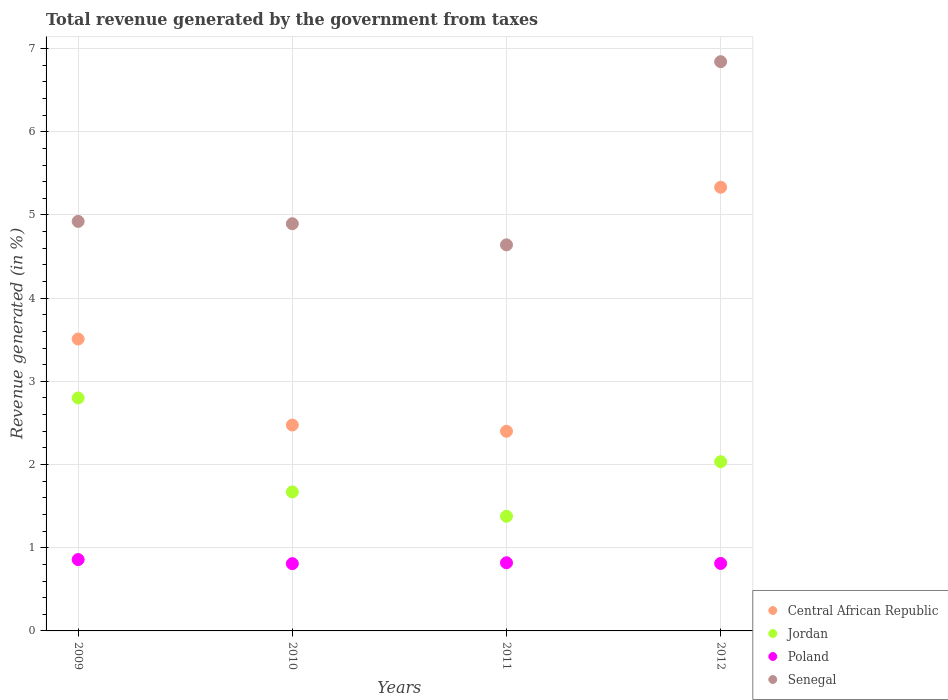How many different coloured dotlines are there?
Make the answer very short. 4. Is the number of dotlines equal to the number of legend labels?
Your answer should be compact. Yes. What is the total revenue generated in Poland in 2012?
Your answer should be very brief. 0.81. Across all years, what is the maximum total revenue generated in Senegal?
Provide a short and direct response. 6.84. Across all years, what is the minimum total revenue generated in Central African Republic?
Your response must be concise. 2.4. What is the total total revenue generated in Jordan in the graph?
Offer a terse response. 7.88. What is the difference between the total revenue generated in Central African Republic in 2011 and that in 2012?
Provide a short and direct response. -2.93. What is the difference between the total revenue generated in Jordan in 2009 and the total revenue generated in Poland in 2010?
Make the answer very short. 1.99. What is the average total revenue generated in Central African Republic per year?
Your response must be concise. 3.43. In the year 2012, what is the difference between the total revenue generated in Jordan and total revenue generated in Senegal?
Ensure brevity in your answer.  -4.81. What is the ratio of the total revenue generated in Jordan in 2009 to that in 2011?
Your response must be concise. 2.03. Is the total revenue generated in Jordan in 2009 less than that in 2012?
Keep it short and to the point. No. Is the difference between the total revenue generated in Jordan in 2011 and 2012 greater than the difference between the total revenue generated in Senegal in 2011 and 2012?
Offer a very short reply. Yes. What is the difference between the highest and the second highest total revenue generated in Central African Republic?
Give a very brief answer. 1.82. What is the difference between the highest and the lowest total revenue generated in Jordan?
Offer a very short reply. 1.42. In how many years, is the total revenue generated in Poland greater than the average total revenue generated in Poland taken over all years?
Ensure brevity in your answer.  1. Is the sum of the total revenue generated in Jordan in 2011 and 2012 greater than the maximum total revenue generated in Central African Republic across all years?
Keep it short and to the point. No. Does the total revenue generated in Poland monotonically increase over the years?
Your answer should be very brief. No. Is the total revenue generated in Central African Republic strictly greater than the total revenue generated in Jordan over the years?
Ensure brevity in your answer.  Yes. Does the graph contain any zero values?
Your answer should be compact. No. Does the graph contain grids?
Your answer should be compact. Yes. Where does the legend appear in the graph?
Your answer should be very brief. Bottom right. How are the legend labels stacked?
Your answer should be very brief. Vertical. What is the title of the graph?
Make the answer very short. Total revenue generated by the government from taxes. Does "Saudi Arabia" appear as one of the legend labels in the graph?
Your response must be concise. No. What is the label or title of the Y-axis?
Your answer should be compact. Revenue generated (in %). What is the Revenue generated (in %) in Central African Republic in 2009?
Offer a very short reply. 3.51. What is the Revenue generated (in %) of Jordan in 2009?
Give a very brief answer. 2.8. What is the Revenue generated (in %) in Poland in 2009?
Your response must be concise. 0.86. What is the Revenue generated (in %) of Senegal in 2009?
Your answer should be compact. 4.92. What is the Revenue generated (in %) in Central African Republic in 2010?
Keep it short and to the point. 2.47. What is the Revenue generated (in %) of Jordan in 2010?
Provide a short and direct response. 1.67. What is the Revenue generated (in %) in Poland in 2010?
Give a very brief answer. 0.81. What is the Revenue generated (in %) of Senegal in 2010?
Ensure brevity in your answer.  4.89. What is the Revenue generated (in %) in Central African Republic in 2011?
Give a very brief answer. 2.4. What is the Revenue generated (in %) of Jordan in 2011?
Your answer should be very brief. 1.38. What is the Revenue generated (in %) of Poland in 2011?
Provide a short and direct response. 0.82. What is the Revenue generated (in %) of Senegal in 2011?
Provide a succinct answer. 4.64. What is the Revenue generated (in %) of Central African Republic in 2012?
Your answer should be compact. 5.33. What is the Revenue generated (in %) in Jordan in 2012?
Your response must be concise. 2.03. What is the Revenue generated (in %) in Poland in 2012?
Provide a short and direct response. 0.81. What is the Revenue generated (in %) of Senegal in 2012?
Offer a terse response. 6.84. Across all years, what is the maximum Revenue generated (in %) of Central African Republic?
Ensure brevity in your answer.  5.33. Across all years, what is the maximum Revenue generated (in %) in Jordan?
Make the answer very short. 2.8. Across all years, what is the maximum Revenue generated (in %) in Poland?
Offer a very short reply. 0.86. Across all years, what is the maximum Revenue generated (in %) of Senegal?
Your answer should be compact. 6.84. Across all years, what is the minimum Revenue generated (in %) of Central African Republic?
Make the answer very short. 2.4. Across all years, what is the minimum Revenue generated (in %) in Jordan?
Ensure brevity in your answer.  1.38. Across all years, what is the minimum Revenue generated (in %) of Poland?
Make the answer very short. 0.81. Across all years, what is the minimum Revenue generated (in %) in Senegal?
Your response must be concise. 4.64. What is the total Revenue generated (in %) in Central African Republic in the graph?
Give a very brief answer. 13.72. What is the total Revenue generated (in %) of Jordan in the graph?
Your response must be concise. 7.88. What is the total Revenue generated (in %) of Poland in the graph?
Offer a terse response. 3.3. What is the total Revenue generated (in %) of Senegal in the graph?
Make the answer very short. 21.3. What is the difference between the Revenue generated (in %) of Central African Republic in 2009 and that in 2010?
Offer a very short reply. 1.03. What is the difference between the Revenue generated (in %) in Jordan in 2009 and that in 2010?
Offer a terse response. 1.13. What is the difference between the Revenue generated (in %) of Poland in 2009 and that in 2010?
Make the answer very short. 0.05. What is the difference between the Revenue generated (in %) in Senegal in 2009 and that in 2010?
Provide a short and direct response. 0.03. What is the difference between the Revenue generated (in %) of Central African Republic in 2009 and that in 2011?
Keep it short and to the point. 1.11. What is the difference between the Revenue generated (in %) of Jordan in 2009 and that in 2011?
Offer a terse response. 1.42. What is the difference between the Revenue generated (in %) in Poland in 2009 and that in 2011?
Make the answer very short. 0.04. What is the difference between the Revenue generated (in %) in Senegal in 2009 and that in 2011?
Keep it short and to the point. 0.28. What is the difference between the Revenue generated (in %) of Central African Republic in 2009 and that in 2012?
Your response must be concise. -1.82. What is the difference between the Revenue generated (in %) in Jordan in 2009 and that in 2012?
Your answer should be very brief. 0.77. What is the difference between the Revenue generated (in %) of Poland in 2009 and that in 2012?
Your answer should be very brief. 0.05. What is the difference between the Revenue generated (in %) in Senegal in 2009 and that in 2012?
Provide a succinct answer. -1.92. What is the difference between the Revenue generated (in %) in Central African Republic in 2010 and that in 2011?
Your answer should be compact. 0.07. What is the difference between the Revenue generated (in %) of Jordan in 2010 and that in 2011?
Make the answer very short. 0.29. What is the difference between the Revenue generated (in %) in Poland in 2010 and that in 2011?
Your answer should be very brief. -0.01. What is the difference between the Revenue generated (in %) in Senegal in 2010 and that in 2011?
Ensure brevity in your answer.  0.25. What is the difference between the Revenue generated (in %) of Central African Republic in 2010 and that in 2012?
Offer a very short reply. -2.86. What is the difference between the Revenue generated (in %) in Jordan in 2010 and that in 2012?
Keep it short and to the point. -0.36. What is the difference between the Revenue generated (in %) in Poland in 2010 and that in 2012?
Provide a short and direct response. -0. What is the difference between the Revenue generated (in %) in Senegal in 2010 and that in 2012?
Provide a succinct answer. -1.95. What is the difference between the Revenue generated (in %) in Central African Republic in 2011 and that in 2012?
Provide a short and direct response. -2.93. What is the difference between the Revenue generated (in %) in Jordan in 2011 and that in 2012?
Your response must be concise. -0.66. What is the difference between the Revenue generated (in %) of Poland in 2011 and that in 2012?
Your answer should be very brief. 0.01. What is the difference between the Revenue generated (in %) in Senegal in 2011 and that in 2012?
Ensure brevity in your answer.  -2.2. What is the difference between the Revenue generated (in %) of Central African Republic in 2009 and the Revenue generated (in %) of Jordan in 2010?
Offer a terse response. 1.84. What is the difference between the Revenue generated (in %) of Central African Republic in 2009 and the Revenue generated (in %) of Poland in 2010?
Ensure brevity in your answer.  2.7. What is the difference between the Revenue generated (in %) of Central African Republic in 2009 and the Revenue generated (in %) of Senegal in 2010?
Ensure brevity in your answer.  -1.39. What is the difference between the Revenue generated (in %) in Jordan in 2009 and the Revenue generated (in %) in Poland in 2010?
Your answer should be compact. 1.99. What is the difference between the Revenue generated (in %) of Jordan in 2009 and the Revenue generated (in %) of Senegal in 2010?
Provide a succinct answer. -2.09. What is the difference between the Revenue generated (in %) of Poland in 2009 and the Revenue generated (in %) of Senegal in 2010?
Your response must be concise. -4.04. What is the difference between the Revenue generated (in %) in Central African Republic in 2009 and the Revenue generated (in %) in Jordan in 2011?
Give a very brief answer. 2.13. What is the difference between the Revenue generated (in %) in Central African Republic in 2009 and the Revenue generated (in %) in Poland in 2011?
Provide a succinct answer. 2.69. What is the difference between the Revenue generated (in %) of Central African Republic in 2009 and the Revenue generated (in %) of Senegal in 2011?
Provide a succinct answer. -1.13. What is the difference between the Revenue generated (in %) of Jordan in 2009 and the Revenue generated (in %) of Poland in 2011?
Your response must be concise. 1.98. What is the difference between the Revenue generated (in %) of Jordan in 2009 and the Revenue generated (in %) of Senegal in 2011?
Ensure brevity in your answer.  -1.84. What is the difference between the Revenue generated (in %) in Poland in 2009 and the Revenue generated (in %) in Senegal in 2011?
Ensure brevity in your answer.  -3.78. What is the difference between the Revenue generated (in %) in Central African Republic in 2009 and the Revenue generated (in %) in Jordan in 2012?
Make the answer very short. 1.47. What is the difference between the Revenue generated (in %) in Central African Republic in 2009 and the Revenue generated (in %) in Poland in 2012?
Offer a terse response. 2.7. What is the difference between the Revenue generated (in %) of Central African Republic in 2009 and the Revenue generated (in %) of Senegal in 2012?
Ensure brevity in your answer.  -3.33. What is the difference between the Revenue generated (in %) of Jordan in 2009 and the Revenue generated (in %) of Poland in 2012?
Ensure brevity in your answer.  1.99. What is the difference between the Revenue generated (in %) in Jordan in 2009 and the Revenue generated (in %) in Senegal in 2012?
Your response must be concise. -4.04. What is the difference between the Revenue generated (in %) of Poland in 2009 and the Revenue generated (in %) of Senegal in 2012?
Give a very brief answer. -5.98. What is the difference between the Revenue generated (in %) of Central African Republic in 2010 and the Revenue generated (in %) of Jordan in 2011?
Make the answer very short. 1.1. What is the difference between the Revenue generated (in %) in Central African Republic in 2010 and the Revenue generated (in %) in Poland in 2011?
Give a very brief answer. 1.66. What is the difference between the Revenue generated (in %) in Central African Republic in 2010 and the Revenue generated (in %) in Senegal in 2011?
Give a very brief answer. -2.17. What is the difference between the Revenue generated (in %) of Jordan in 2010 and the Revenue generated (in %) of Poland in 2011?
Ensure brevity in your answer.  0.85. What is the difference between the Revenue generated (in %) in Jordan in 2010 and the Revenue generated (in %) in Senegal in 2011?
Keep it short and to the point. -2.97. What is the difference between the Revenue generated (in %) of Poland in 2010 and the Revenue generated (in %) of Senegal in 2011?
Your answer should be very brief. -3.83. What is the difference between the Revenue generated (in %) of Central African Republic in 2010 and the Revenue generated (in %) of Jordan in 2012?
Offer a terse response. 0.44. What is the difference between the Revenue generated (in %) of Central African Republic in 2010 and the Revenue generated (in %) of Poland in 2012?
Your response must be concise. 1.66. What is the difference between the Revenue generated (in %) in Central African Republic in 2010 and the Revenue generated (in %) in Senegal in 2012?
Ensure brevity in your answer.  -4.37. What is the difference between the Revenue generated (in %) of Jordan in 2010 and the Revenue generated (in %) of Poland in 2012?
Keep it short and to the point. 0.86. What is the difference between the Revenue generated (in %) in Jordan in 2010 and the Revenue generated (in %) in Senegal in 2012?
Make the answer very short. -5.17. What is the difference between the Revenue generated (in %) of Poland in 2010 and the Revenue generated (in %) of Senegal in 2012?
Offer a very short reply. -6.03. What is the difference between the Revenue generated (in %) of Central African Republic in 2011 and the Revenue generated (in %) of Jordan in 2012?
Provide a short and direct response. 0.37. What is the difference between the Revenue generated (in %) in Central African Republic in 2011 and the Revenue generated (in %) in Poland in 2012?
Ensure brevity in your answer.  1.59. What is the difference between the Revenue generated (in %) in Central African Republic in 2011 and the Revenue generated (in %) in Senegal in 2012?
Ensure brevity in your answer.  -4.44. What is the difference between the Revenue generated (in %) in Jordan in 2011 and the Revenue generated (in %) in Poland in 2012?
Give a very brief answer. 0.57. What is the difference between the Revenue generated (in %) of Jordan in 2011 and the Revenue generated (in %) of Senegal in 2012?
Your answer should be compact. -5.46. What is the difference between the Revenue generated (in %) in Poland in 2011 and the Revenue generated (in %) in Senegal in 2012?
Provide a succinct answer. -6.02. What is the average Revenue generated (in %) in Central African Republic per year?
Give a very brief answer. 3.43. What is the average Revenue generated (in %) of Jordan per year?
Provide a succinct answer. 1.97. What is the average Revenue generated (in %) of Poland per year?
Your response must be concise. 0.82. What is the average Revenue generated (in %) in Senegal per year?
Make the answer very short. 5.33. In the year 2009, what is the difference between the Revenue generated (in %) of Central African Republic and Revenue generated (in %) of Jordan?
Your response must be concise. 0.71. In the year 2009, what is the difference between the Revenue generated (in %) of Central African Republic and Revenue generated (in %) of Poland?
Keep it short and to the point. 2.65. In the year 2009, what is the difference between the Revenue generated (in %) in Central African Republic and Revenue generated (in %) in Senegal?
Your answer should be very brief. -1.41. In the year 2009, what is the difference between the Revenue generated (in %) in Jordan and Revenue generated (in %) in Poland?
Give a very brief answer. 1.94. In the year 2009, what is the difference between the Revenue generated (in %) in Jordan and Revenue generated (in %) in Senegal?
Give a very brief answer. -2.12. In the year 2009, what is the difference between the Revenue generated (in %) of Poland and Revenue generated (in %) of Senegal?
Offer a terse response. -4.06. In the year 2010, what is the difference between the Revenue generated (in %) in Central African Republic and Revenue generated (in %) in Jordan?
Provide a short and direct response. 0.8. In the year 2010, what is the difference between the Revenue generated (in %) in Central African Republic and Revenue generated (in %) in Poland?
Give a very brief answer. 1.67. In the year 2010, what is the difference between the Revenue generated (in %) of Central African Republic and Revenue generated (in %) of Senegal?
Make the answer very short. -2.42. In the year 2010, what is the difference between the Revenue generated (in %) of Jordan and Revenue generated (in %) of Poland?
Ensure brevity in your answer.  0.86. In the year 2010, what is the difference between the Revenue generated (in %) in Jordan and Revenue generated (in %) in Senegal?
Your answer should be compact. -3.22. In the year 2010, what is the difference between the Revenue generated (in %) of Poland and Revenue generated (in %) of Senegal?
Your response must be concise. -4.09. In the year 2011, what is the difference between the Revenue generated (in %) of Central African Republic and Revenue generated (in %) of Jordan?
Your answer should be compact. 1.02. In the year 2011, what is the difference between the Revenue generated (in %) in Central African Republic and Revenue generated (in %) in Poland?
Offer a terse response. 1.58. In the year 2011, what is the difference between the Revenue generated (in %) in Central African Republic and Revenue generated (in %) in Senegal?
Offer a very short reply. -2.24. In the year 2011, what is the difference between the Revenue generated (in %) of Jordan and Revenue generated (in %) of Poland?
Your answer should be compact. 0.56. In the year 2011, what is the difference between the Revenue generated (in %) of Jordan and Revenue generated (in %) of Senegal?
Provide a short and direct response. -3.26. In the year 2011, what is the difference between the Revenue generated (in %) in Poland and Revenue generated (in %) in Senegal?
Keep it short and to the point. -3.82. In the year 2012, what is the difference between the Revenue generated (in %) of Central African Republic and Revenue generated (in %) of Jordan?
Keep it short and to the point. 3.3. In the year 2012, what is the difference between the Revenue generated (in %) of Central African Republic and Revenue generated (in %) of Poland?
Give a very brief answer. 4.52. In the year 2012, what is the difference between the Revenue generated (in %) of Central African Republic and Revenue generated (in %) of Senegal?
Your response must be concise. -1.51. In the year 2012, what is the difference between the Revenue generated (in %) of Jordan and Revenue generated (in %) of Poland?
Offer a very short reply. 1.22. In the year 2012, what is the difference between the Revenue generated (in %) in Jordan and Revenue generated (in %) in Senegal?
Your answer should be compact. -4.81. In the year 2012, what is the difference between the Revenue generated (in %) of Poland and Revenue generated (in %) of Senegal?
Make the answer very short. -6.03. What is the ratio of the Revenue generated (in %) in Central African Republic in 2009 to that in 2010?
Your answer should be very brief. 1.42. What is the ratio of the Revenue generated (in %) of Jordan in 2009 to that in 2010?
Provide a short and direct response. 1.68. What is the ratio of the Revenue generated (in %) of Poland in 2009 to that in 2010?
Ensure brevity in your answer.  1.06. What is the ratio of the Revenue generated (in %) of Central African Republic in 2009 to that in 2011?
Ensure brevity in your answer.  1.46. What is the ratio of the Revenue generated (in %) of Jordan in 2009 to that in 2011?
Make the answer very short. 2.03. What is the ratio of the Revenue generated (in %) of Poland in 2009 to that in 2011?
Make the answer very short. 1.05. What is the ratio of the Revenue generated (in %) of Senegal in 2009 to that in 2011?
Make the answer very short. 1.06. What is the ratio of the Revenue generated (in %) in Central African Republic in 2009 to that in 2012?
Your answer should be very brief. 0.66. What is the ratio of the Revenue generated (in %) in Jordan in 2009 to that in 2012?
Your answer should be compact. 1.38. What is the ratio of the Revenue generated (in %) of Poland in 2009 to that in 2012?
Offer a very short reply. 1.06. What is the ratio of the Revenue generated (in %) in Senegal in 2009 to that in 2012?
Give a very brief answer. 0.72. What is the ratio of the Revenue generated (in %) of Central African Republic in 2010 to that in 2011?
Provide a succinct answer. 1.03. What is the ratio of the Revenue generated (in %) of Jordan in 2010 to that in 2011?
Your answer should be very brief. 1.21. What is the ratio of the Revenue generated (in %) in Poland in 2010 to that in 2011?
Keep it short and to the point. 0.99. What is the ratio of the Revenue generated (in %) in Senegal in 2010 to that in 2011?
Provide a succinct answer. 1.05. What is the ratio of the Revenue generated (in %) of Central African Republic in 2010 to that in 2012?
Ensure brevity in your answer.  0.46. What is the ratio of the Revenue generated (in %) of Jordan in 2010 to that in 2012?
Provide a succinct answer. 0.82. What is the ratio of the Revenue generated (in %) of Senegal in 2010 to that in 2012?
Provide a succinct answer. 0.72. What is the ratio of the Revenue generated (in %) in Central African Republic in 2011 to that in 2012?
Ensure brevity in your answer.  0.45. What is the ratio of the Revenue generated (in %) of Jordan in 2011 to that in 2012?
Provide a short and direct response. 0.68. What is the ratio of the Revenue generated (in %) of Poland in 2011 to that in 2012?
Provide a short and direct response. 1.01. What is the ratio of the Revenue generated (in %) in Senegal in 2011 to that in 2012?
Give a very brief answer. 0.68. What is the difference between the highest and the second highest Revenue generated (in %) in Central African Republic?
Offer a very short reply. 1.82. What is the difference between the highest and the second highest Revenue generated (in %) of Jordan?
Provide a succinct answer. 0.77. What is the difference between the highest and the second highest Revenue generated (in %) in Poland?
Provide a succinct answer. 0.04. What is the difference between the highest and the second highest Revenue generated (in %) of Senegal?
Provide a short and direct response. 1.92. What is the difference between the highest and the lowest Revenue generated (in %) of Central African Republic?
Your response must be concise. 2.93. What is the difference between the highest and the lowest Revenue generated (in %) in Jordan?
Your response must be concise. 1.42. What is the difference between the highest and the lowest Revenue generated (in %) of Poland?
Offer a very short reply. 0.05. What is the difference between the highest and the lowest Revenue generated (in %) in Senegal?
Ensure brevity in your answer.  2.2. 